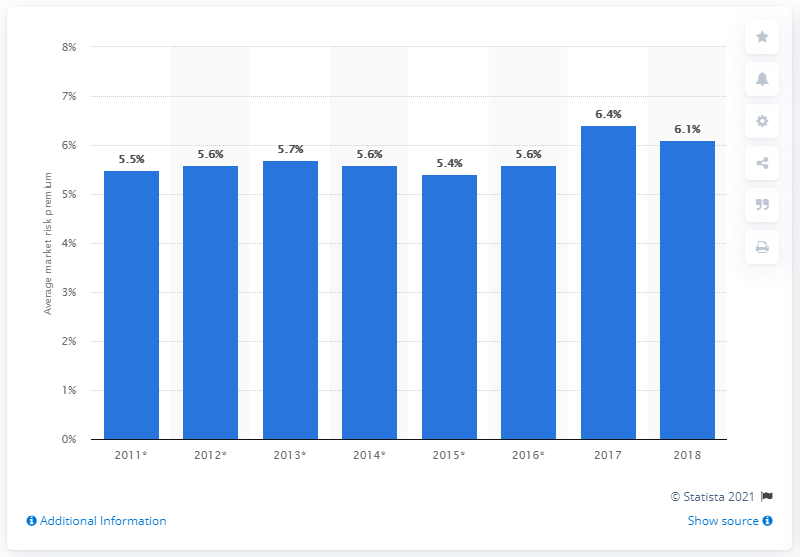Specify some key components in this picture. The value of the MRP in 2018 was 6.1. 